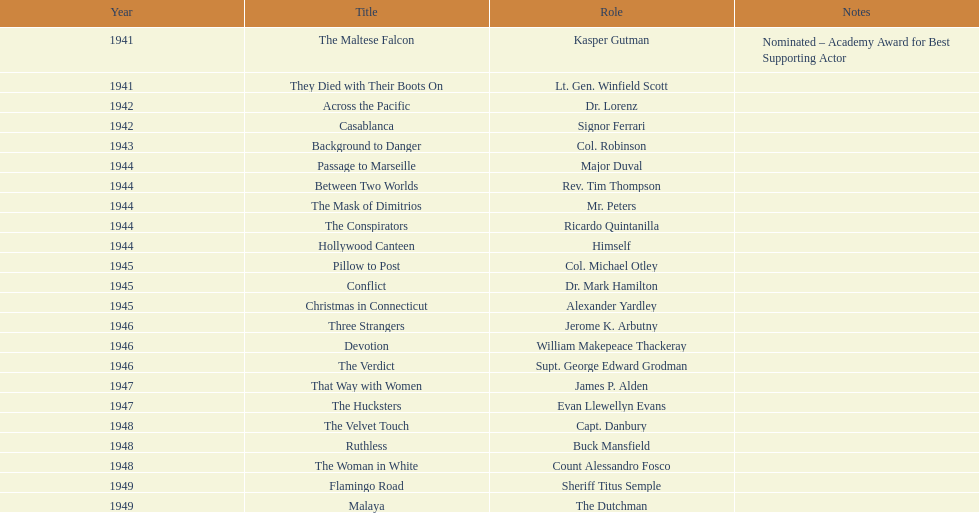For which film did he receive an oscar nomination? The Maltese Falcon. 